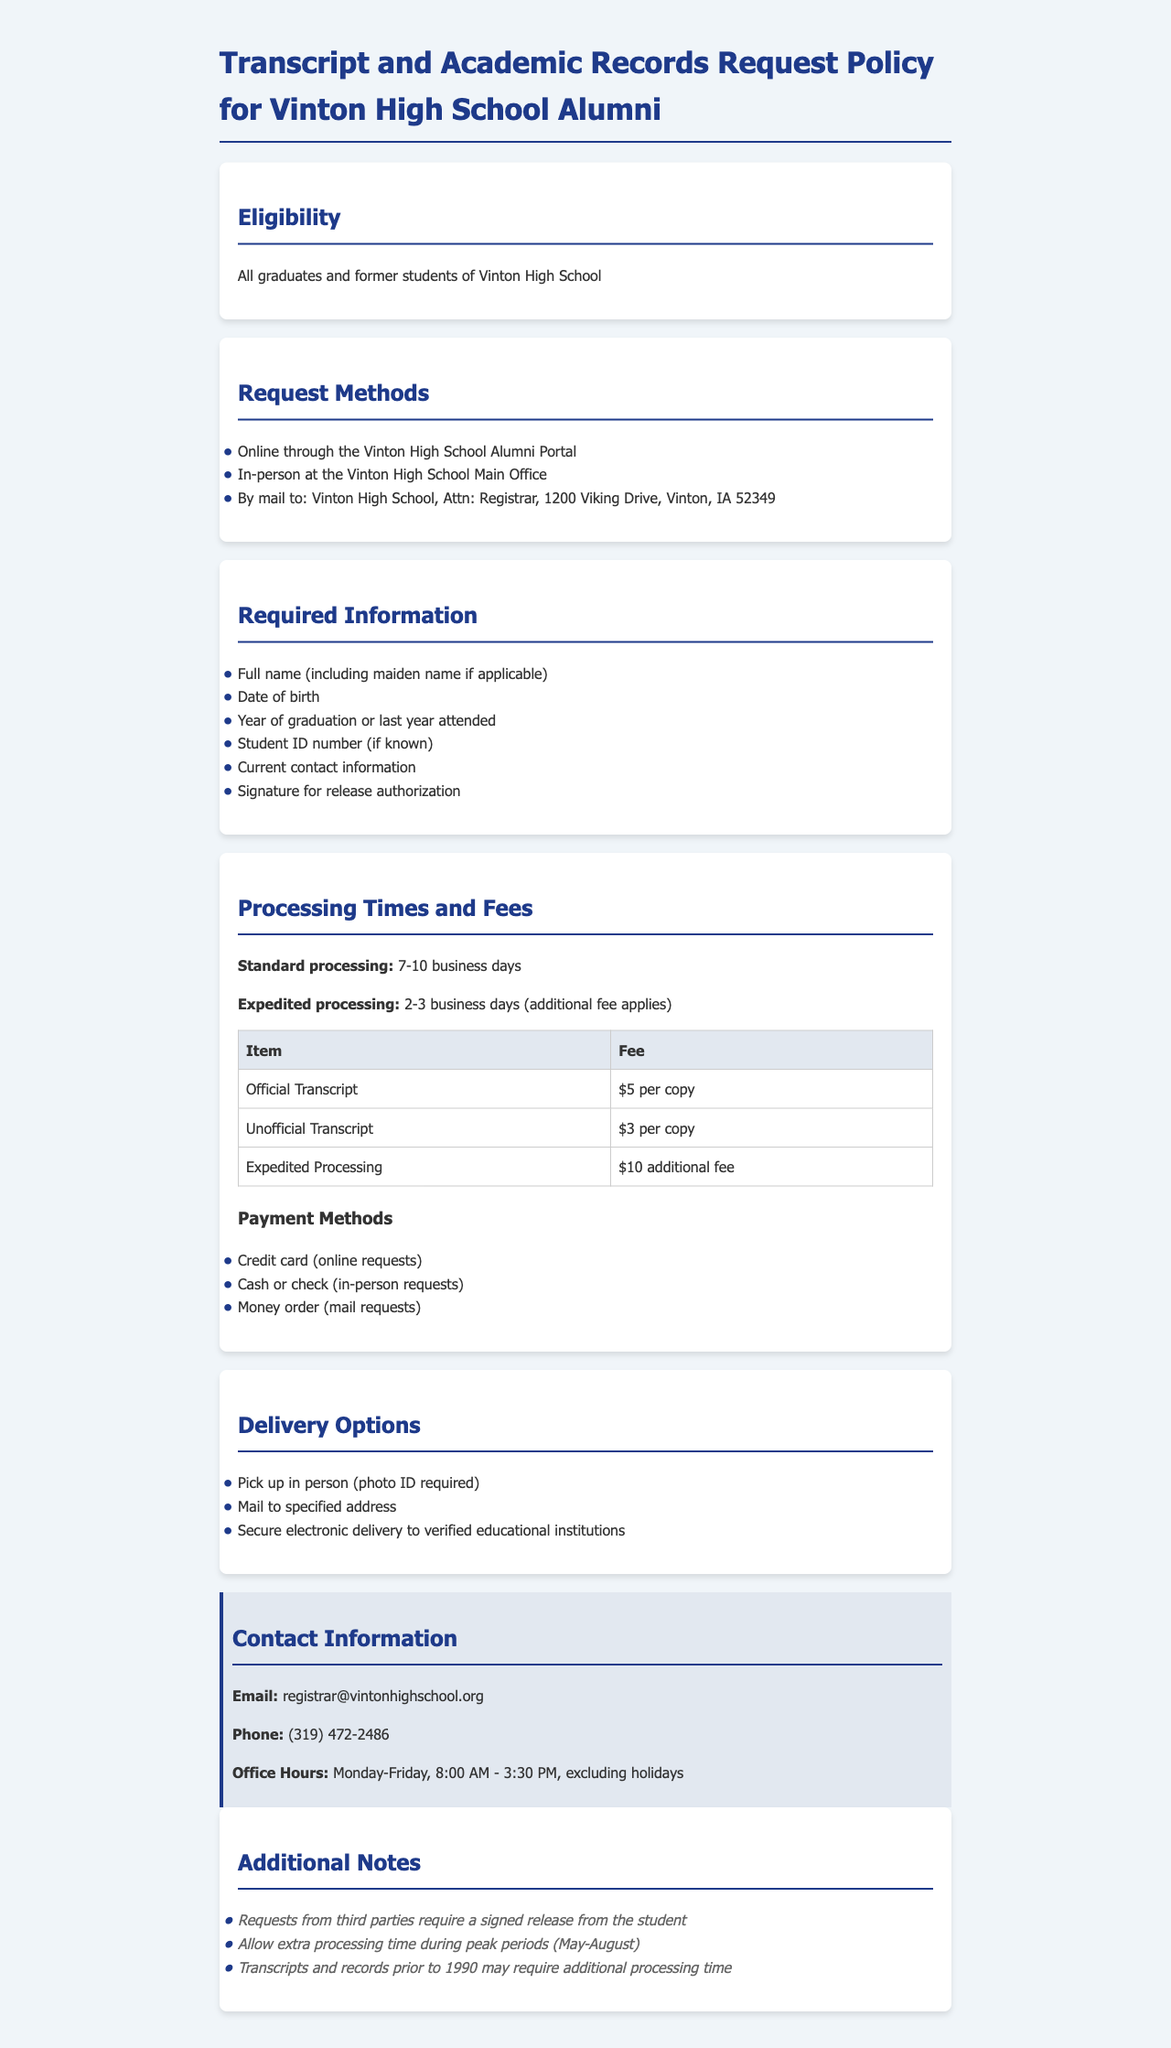What is the standard processing time for transcript requests? The standard processing time is stated in the document as 7-10 business days.
Answer: 7-10 business days What are the fees for an official transcript? The document specifies the fee for an official transcript as $5 per copy.
Answer: $5 per copy What additional fee is required for expedited processing? The document mentions an additional fee for expedited processing, which is $10.
Answer: $10 What is the eligibility requirement to request transcripts? The eligibility requirement is that the requestor must be an alumnus or former student of Vinton High School.
Answer: All graduates and former students What delivery option requires a photo ID? The delivery option that requires a photo ID is in-person pickup.
Answer: Pick up in person What should be included in the required information for requests? The required information includes full name, date of birth, year of graduation, student ID number, current contact information, and signature for release.
Answer: Full name (including maiden name if applicable), date of birth, year of graduation or last year attended, student ID number (if known), current contact information, signature for release authorization During which months should extra processing time be allowed? Extra processing time should be allowed during the peak periods of May to August.
Answer: May-August What is the email address for the registrar? The contact information section provides the registrar's email as registrar@vintonhighschool.org.
Answer: registrar@vintonhighschool.org 